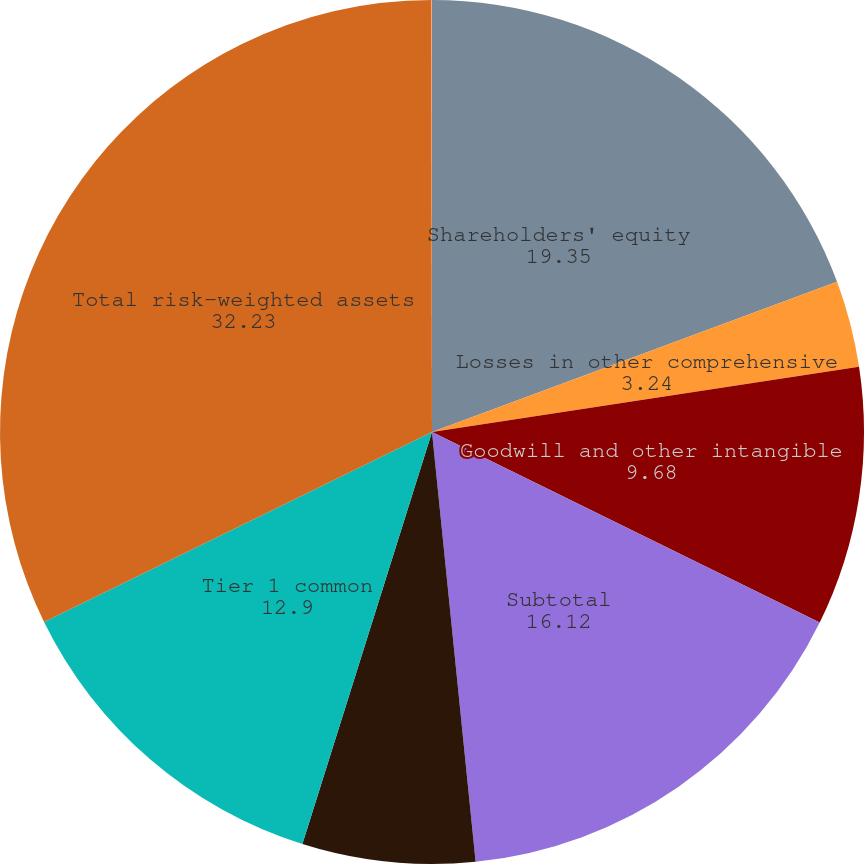<chart> <loc_0><loc_0><loc_500><loc_500><pie_chart><fcel>Shareholders' equity<fcel>Losses in other comprehensive<fcel>Goodwill and other intangible<fcel>Subtotal<fcel>Disallowed servicing assets<fcel>Tier 1 common<fcel>Total risk-weighted assets<fcel>Tier 1 common ratio (Tier 1<nl><fcel>19.35%<fcel>3.24%<fcel>9.68%<fcel>16.12%<fcel>6.46%<fcel>12.9%<fcel>32.23%<fcel>0.02%<nl></chart> 